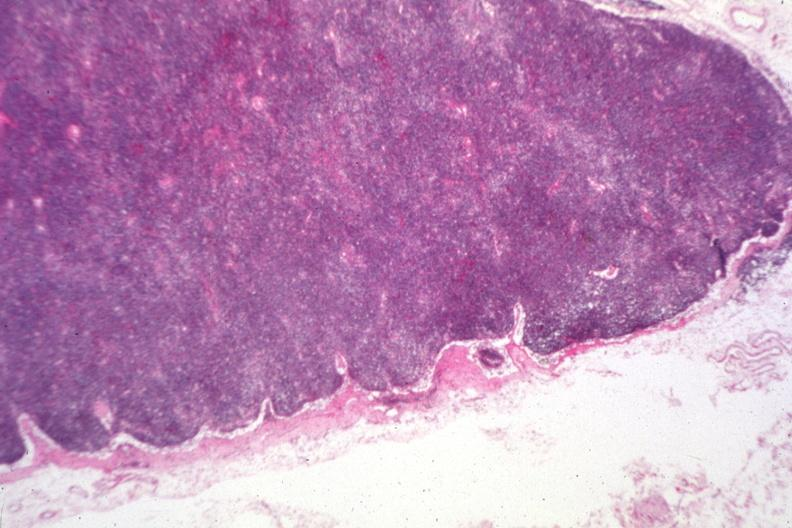what is present?
Answer the question using a single word or phrase. Lymph node 